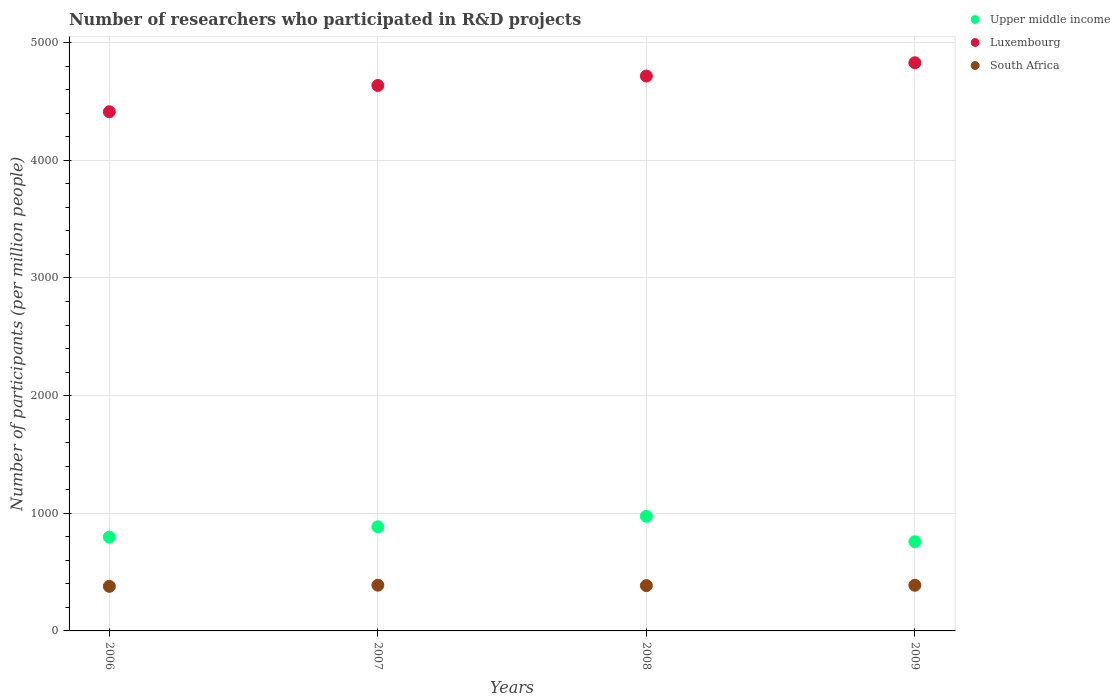How many different coloured dotlines are there?
Offer a terse response. 3. What is the number of researchers who participated in R&D projects in South Africa in 2007?
Make the answer very short. 388.79. Across all years, what is the maximum number of researchers who participated in R&D projects in South Africa?
Your answer should be very brief. 388.79. Across all years, what is the minimum number of researchers who participated in R&D projects in South Africa?
Give a very brief answer. 378.82. In which year was the number of researchers who participated in R&D projects in Upper middle income maximum?
Give a very brief answer. 2008. In which year was the number of researchers who participated in R&D projects in Upper middle income minimum?
Make the answer very short. 2009. What is the total number of researchers who participated in R&D projects in South Africa in the graph?
Your answer should be very brief. 1540.77. What is the difference between the number of researchers who participated in R&D projects in Upper middle income in 2008 and that in 2009?
Keep it short and to the point. 215.88. What is the difference between the number of researchers who participated in R&D projects in Upper middle income in 2006 and the number of researchers who participated in R&D projects in Luxembourg in 2007?
Your response must be concise. -3838.34. What is the average number of researchers who participated in R&D projects in Luxembourg per year?
Your response must be concise. 4648.26. In the year 2007, what is the difference between the number of researchers who participated in R&D projects in Luxembourg and number of researchers who participated in R&D projects in South Africa?
Your response must be concise. 4246.93. In how many years, is the number of researchers who participated in R&D projects in Upper middle income greater than 800?
Offer a very short reply. 2. What is the ratio of the number of researchers who participated in R&D projects in Luxembourg in 2007 to that in 2008?
Your answer should be compact. 0.98. What is the difference between the highest and the second highest number of researchers who participated in R&D projects in Upper middle income?
Provide a succinct answer. 88.72. What is the difference between the highest and the lowest number of researchers who participated in R&D projects in South Africa?
Provide a succinct answer. 9.97. Is it the case that in every year, the sum of the number of researchers who participated in R&D projects in Upper middle income and number of researchers who participated in R&D projects in Luxembourg  is greater than the number of researchers who participated in R&D projects in South Africa?
Make the answer very short. Yes. Is the number of researchers who participated in R&D projects in South Africa strictly greater than the number of researchers who participated in R&D projects in Luxembourg over the years?
Offer a terse response. No. How many dotlines are there?
Give a very brief answer. 3. How many years are there in the graph?
Keep it short and to the point. 4. Are the values on the major ticks of Y-axis written in scientific E-notation?
Provide a short and direct response. No. How many legend labels are there?
Keep it short and to the point. 3. How are the legend labels stacked?
Give a very brief answer. Vertical. What is the title of the graph?
Offer a very short reply. Number of researchers who participated in R&D projects. What is the label or title of the X-axis?
Provide a succinct answer. Years. What is the label or title of the Y-axis?
Provide a succinct answer. Number of participants (per million people). What is the Number of participants (per million people) in Upper middle income in 2006?
Provide a succinct answer. 797.38. What is the Number of participants (per million people) in Luxembourg in 2006?
Your answer should be very brief. 4412.45. What is the Number of participants (per million people) in South Africa in 2006?
Your answer should be compact. 378.82. What is the Number of participants (per million people) in Upper middle income in 2007?
Ensure brevity in your answer.  885.24. What is the Number of participants (per million people) of Luxembourg in 2007?
Provide a succinct answer. 4635.72. What is the Number of participants (per million people) in South Africa in 2007?
Provide a succinct answer. 388.79. What is the Number of participants (per million people) of Upper middle income in 2008?
Provide a short and direct response. 973.96. What is the Number of participants (per million people) in Luxembourg in 2008?
Keep it short and to the point. 4715.93. What is the Number of participants (per million people) of South Africa in 2008?
Give a very brief answer. 385. What is the Number of participants (per million people) in Upper middle income in 2009?
Your response must be concise. 758.08. What is the Number of participants (per million people) in Luxembourg in 2009?
Provide a succinct answer. 4828.95. What is the Number of participants (per million people) in South Africa in 2009?
Your response must be concise. 388.16. Across all years, what is the maximum Number of participants (per million people) in Upper middle income?
Your answer should be very brief. 973.96. Across all years, what is the maximum Number of participants (per million people) in Luxembourg?
Provide a succinct answer. 4828.95. Across all years, what is the maximum Number of participants (per million people) of South Africa?
Your answer should be very brief. 388.79. Across all years, what is the minimum Number of participants (per million people) in Upper middle income?
Provide a succinct answer. 758.08. Across all years, what is the minimum Number of participants (per million people) of Luxembourg?
Your answer should be compact. 4412.45. Across all years, what is the minimum Number of participants (per million people) of South Africa?
Give a very brief answer. 378.82. What is the total Number of participants (per million people) of Upper middle income in the graph?
Your answer should be very brief. 3414.66. What is the total Number of participants (per million people) in Luxembourg in the graph?
Offer a terse response. 1.86e+04. What is the total Number of participants (per million people) of South Africa in the graph?
Provide a succinct answer. 1540.77. What is the difference between the Number of participants (per million people) in Upper middle income in 2006 and that in 2007?
Your response must be concise. -87.86. What is the difference between the Number of participants (per million people) of Luxembourg in 2006 and that in 2007?
Ensure brevity in your answer.  -223.27. What is the difference between the Number of participants (per million people) in South Africa in 2006 and that in 2007?
Offer a very short reply. -9.97. What is the difference between the Number of participants (per million people) in Upper middle income in 2006 and that in 2008?
Keep it short and to the point. -176.58. What is the difference between the Number of participants (per million people) in Luxembourg in 2006 and that in 2008?
Provide a short and direct response. -303.48. What is the difference between the Number of participants (per million people) in South Africa in 2006 and that in 2008?
Your answer should be compact. -6.18. What is the difference between the Number of participants (per million people) of Upper middle income in 2006 and that in 2009?
Give a very brief answer. 39.31. What is the difference between the Number of participants (per million people) of Luxembourg in 2006 and that in 2009?
Give a very brief answer. -416.5. What is the difference between the Number of participants (per million people) of South Africa in 2006 and that in 2009?
Make the answer very short. -9.34. What is the difference between the Number of participants (per million people) of Upper middle income in 2007 and that in 2008?
Your answer should be compact. -88.72. What is the difference between the Number of participants (per million people) in Luxembourg in 2007 and that in 2008?
Your answer should be compact. -80.21. What is the difference between the Number of participants (per million people) of South Africa in 2007 and that in 2008?
Your answer should be very brief. 3.79. What is the difference between the Number of participants (per million people) of Upper middle income in 2007 and that in 2009?
Offer a terse response. 127.16. What is the difference between the Number of participants (per million people) of Luxembourg in 2007 and that in 2009?
Provide a succinct answer. -193.23. What is the difference between the Number of participants (per million people) of South Africa in 2007 and that in 2009?
Provide a short and direct response. 0.63. What is the difference between the Number of participants (per million people) in Upper middle income in 2008 and that in 2009?
Provide a succinct answer. 215.88. What is the difference between the Number of participants (per million people) in Luxembourg in 2008 and that in 2009?
Offer a terse response. -113.02. What is the difference between the Number of participants (per million people) in South Africa in 2008 and that in 2009?
Your answer should be compact. -3.16. What is the difference between the Number of participants (per million people) of Upper middle income in 2006 and the Number of participants (per million people) of Luxembourg in 2007?
Offer a very short reply. -3838.34. What is the difference between the Number of participants (per million people) of Upper middle income in 2006 and the Number of participants (per million people) of South Africa in 2007?
Provide a succinct answer. 408.59. What is the difference between the Number of participants (per million people) of Luxembourg in 2006 and the Number of participants (per million people) of South Africa in 2007?
Offer a very short reply. 4023.67. What is the difference between the Number of participants (per million people) in Upper middle income in 2006 and the Number of participants (per million people) in Luxembourg in 2008?
Offer a terse response. -3918.55. What is the difference between the Number of participants (per million people) of Upper middle income in 2006 and the Number of participants (per million people) of South Africa in 2008?
Give a very brief answer. 412.38. What is the difference between the Number of participants (per million people) of Luxembourg in 2006 and the Number of participants (per million people) of South Africa in 2008?
Make the answer very short. 4027.45. What is the difference between the Number of participants (per million people) of Upper middle income in 2006 and the Number of participants (per million people) of Luxembourg in 2009?
Offer a terse response. -4031.57. What is the difference between the Number of participants (per million people) in Upper middle income in 2006 and the Number of participants (per million people) in South Africa in 2009?
Keep it short and to the point. 409.22. What is the difference between the Number of participants (per million people) in Luxembourg in 2006 and the Number of participants (per million people) in South Africa in 2009?
Keep it short and to the point. 4024.29. What is the difference between the Number of participants (per million people) of Upper middle income in 2007 and the Number of participants (per million people) of Luxembourg in 2008?
Your answer should be very brief. -3830.69. What is the difference between the Number of participants (per million people) of Upper middle income in 2007 and the Number of participants (per million people) of South Africa in 2008?
Your response must be concise. 500.24. What is the difference between the Number of participants (per million people) in Luxembourg in 2007 and the Number of participants (per million people) in South Africa in 2008?
Offer a very short reply. 4250.72. What is the difference between the Number of participants (per million people) in Upper middle income in 2007 and the Number of participants (per million people) in Luxembourg in 2009?
Offer a very short reply. -3943.71. What is the difference between the Number of participants (per million people) in Upper middle income in 2007 and the Number of participants (per million people) in South Africa in 2009?
Your answer should be very brief. 497.08. What is the difference between the Number of participants (per million people) of Luxembourg in 2007 and the Number of participants (per million people) of South Africa in 2009?
Offer a terse response. 4247.56. What is the difference between the Number of participants (per million people) of Upper middle income in 2008 and the Number of participants (per million people) of Luxembourg in 2009?
Your response must be concise. -3854.99. What is the difference between the Number of participants (per million people) of Upper middle income in 2008 and the Number of participants (per million people) of South Africa in 2009?
Your response must be concise. 585.8. What is the difference between the Number of participants (per million people) of Luxembourg in 2008 and the Number of participants (per million people) of South Africa in 2009?
Make the answer very short. 4327.77. What is the average Number of participants (per million people) of Upper middle income per year?
Your response must be concise. 853.67. What is the average Number of participants (per million people) in Luxembourg per year?
Your answer should be very brief. 4648.26. What is the average Number of participants (per million people) in South Africa per year?
Make the answer very short. 385.19. In the year 2006, what is the difference between the Number of participants (per million people) of Upper middle income and Number of participants (per million people) of Luxembourg?
Ensure brevity in your answer.  -3615.07. In the year 2006, what is the difference between the Number of participants (per million people) in Upper middle income and Number of participants (per million people) in South Africa?
Provide a short and direct response. 418.56. In the year 2006, what is the difference between the Number of participants (per million people) in Luxembourg and Number of participants (per million people) in South Africa?
Ensure brevity in your answer.  4033.63. In the year 2007, what is the difference between the Number of participants (per million people) in Upper middle income and Number of participants (per million people) in Luxembourg?
Offer a terse response. -3750.48. In the year 2007, what is the difference between the Number of participants (per million people) of Upper middle income and Number of participants (per million people) of South Africa?
Make the answer very short. 496.45. In the year 2007, what is the difference between the Number of participants (per million people) of Luxembourg and Number of participants (per million people) of South Africa?
Make the answer very short. 4246.93. In the year 2008, what is the difference between the Number of participants (per million people) in Upper middle income and Number of participants (per million people) in Luxembourg?
Make the answer very short. -3741.97. In the year 2008, what is the difference between the Number of participants (per million people) in Upper middle income and Number of participants (per million people) in South Africa?
Your answer should be compact. 588.96. In the year 2008, what is the difference between the Number of participants (per million people) of Luxembourg and Number of participants (per million people) of South Africa?
Keep it short and to the point. 4330.93. In the year 2009, what is the difference between the Number of participants (per million people) in Upper middle income and Number of participants (per million people) in Luxembourg?
Provide a succinct answer. -4070.87. In the year 2009, what is the difference between the Number of participants (per million people) in Upper middle income and Number of participants (per million people) in South Africa?
Provide a short and direct response. 369.92. In the year 2009, what is the difference between the Number of participants (per million people) of Luxembourg and Number of participants (per million people) of South Africa?
Give a very brief answer. 4440.79. What is the ratio of the Number of participants (per million people) of Upper middle income in 2006 to that in 2007?
Offer a very short reply. 0.9. What is the ratio of the Number of participants (per million people) in Luxembourg in 2006 to that in 2007?
Your answer should be very brief. 0.95. What is the ratio of the Number of participants (per million people) in South Africa in 2006 to that in 2007?
Provide a short and direct response. 0.97. What is the ratio of the Number of participants (per million people) in Upper middle income in 2006 to that in 2008?
Ensure brevity in your answer.  0.82. What is the ratio of the Number of participants (per million people) in Luxembourg in 2006 to that in 2008?
Ensure brevity in your answer.  0.94. What is the ratio of the Number of participants (per million people) of South Africa in 2006 to that in 2008?
Give a very brief answer. 0.98. What is the ratio of the Number of participants (per million people) in Upper middle income in 2006 to that in 2009?
Ensure brevity in your answer.  1.05. What is the ratio of the Number of participants (per million people) of Luxembourg in 2006 to that in 2009?
Provide a succinct answer. 0.91. What is the ratio of the Number of participants (per million people) in South Africa in 2006 to that in 2009?
Offer a very short reply. 0.98. What is the ratio of the Number of participants (per million people) of Upper middle income in 2007 to that in 2008?
Offer a terse response. 0.91. What is the ratio of the Number of participants (per million people) of Luxembourg in 2007 to that in 2008?
Offer a very short reply. 0.98. What is the ratio of the Number of participants (per million people) in South Africa in 2007 to that in 2008?
Your answer should be compact. 1.01. What is the ratio of the Number of participants (per million people) of Upper middle income in 2007 to that in 2009?
Make the answer very short. 1.17. What is the ratio of the Number of participants (per million people) in Luxembourg in 2007 to that in 2009?
Your answer should be compact. 0.96. What is the ratio of the Number of participants (per million people) in South Africa in 2007 to that in 2009?
Make the answer very short. 1. What is the ratio of the Number of participants (per million people) of Upper middle income in 2008 to that in 2009?
Your response must be concise. 1.28. What is the ratio of the Number of participants (per million people) in Luxembourg in 2008 to that in 2009?
Provide a short and direct response. 0.98. What is the difference between the highest and the second highest Number of participants (per million people) in Upper middle income?
Give a very brief answer. 88.72. What is the difference between the highest and the second highest Number of participants (per million people) of Luxembourg?
Ensure brevity in your answer.  113.02. What is the difference between the highest and the second highest Number of participants (per million people) in South Africa?
Make the answer very short. 0.63. What is the difference between the highest and the lowest Number of participants (per million people) in Upper middle income?
Offer a terse response. 215.88. What is the difference between the highest and the lowest Number of participants (per million people) in Luxembourg?
Provide a short and direct response. 416.5. What is the difference between the highest and the lowest Number of participants (per million people) of South Africa?
Ensure brevity in your answer.  9.97. 